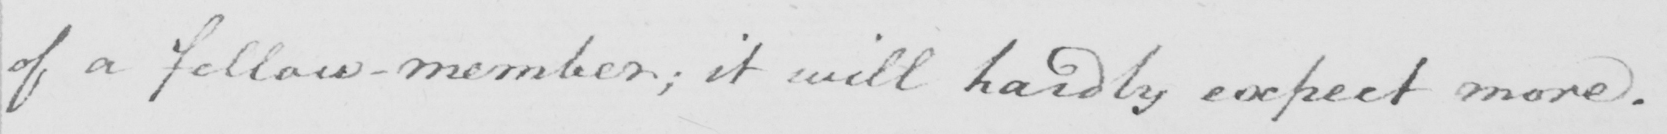What text is written in this handwritten line? of a fellow member; it will hardly expect more. 